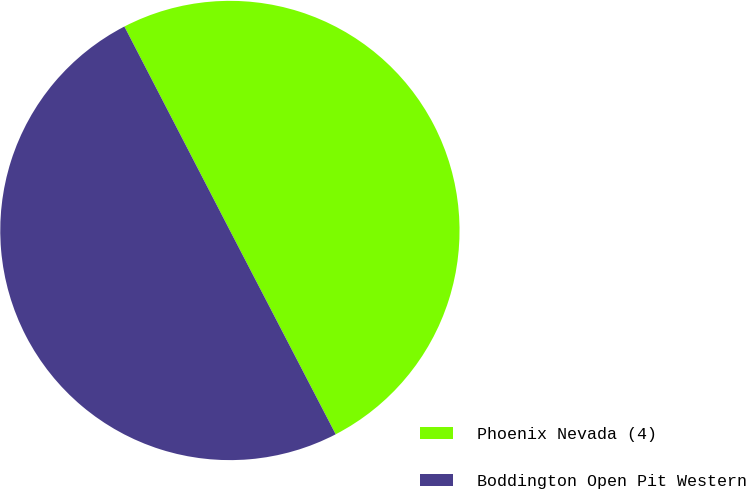<chart> <loc_0><loc_0><loc_500><loc_500><pie_chart><fcel>Phoenix Nevada (4)<fcel>Boddington Open Pit Western<nl><fcel>49.98%<fcel>50.02%<nl></chart> 